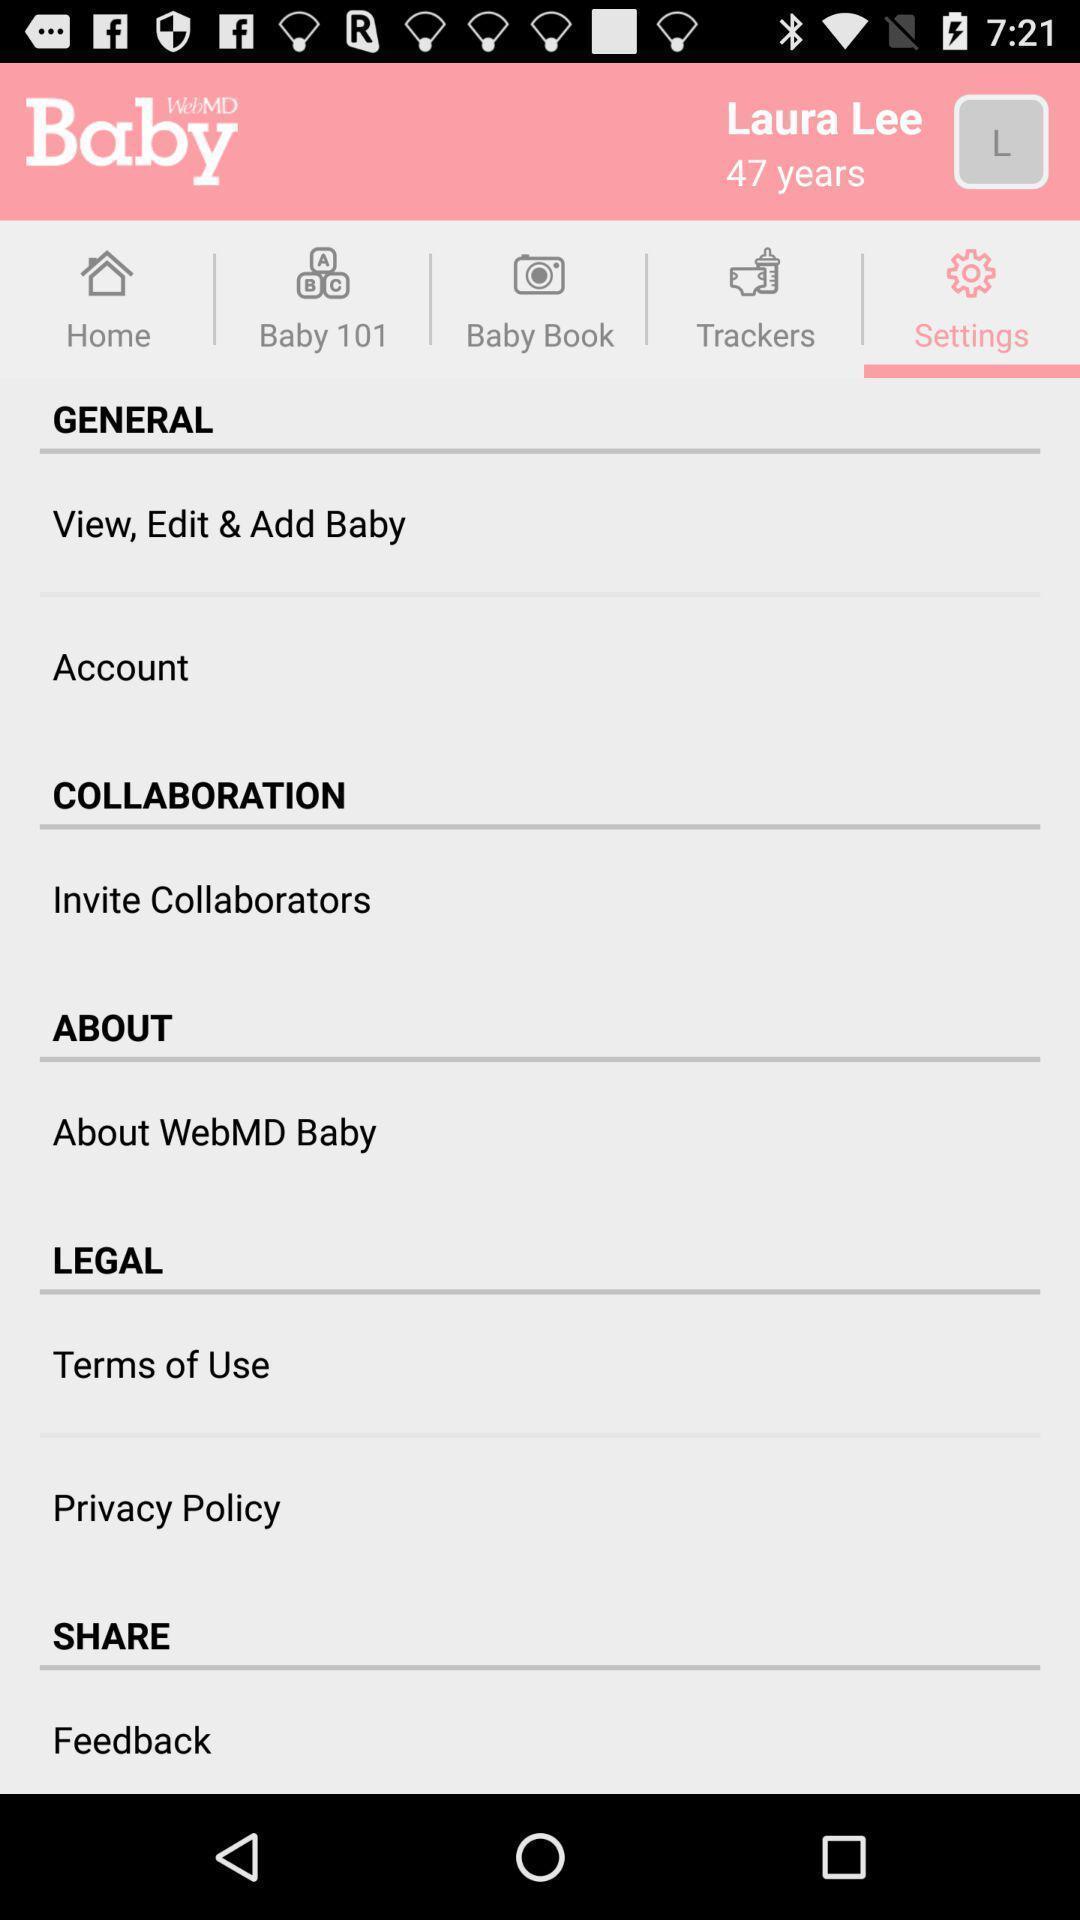Provide a textual representation of this image. Settings page of a baby healthcare app. 